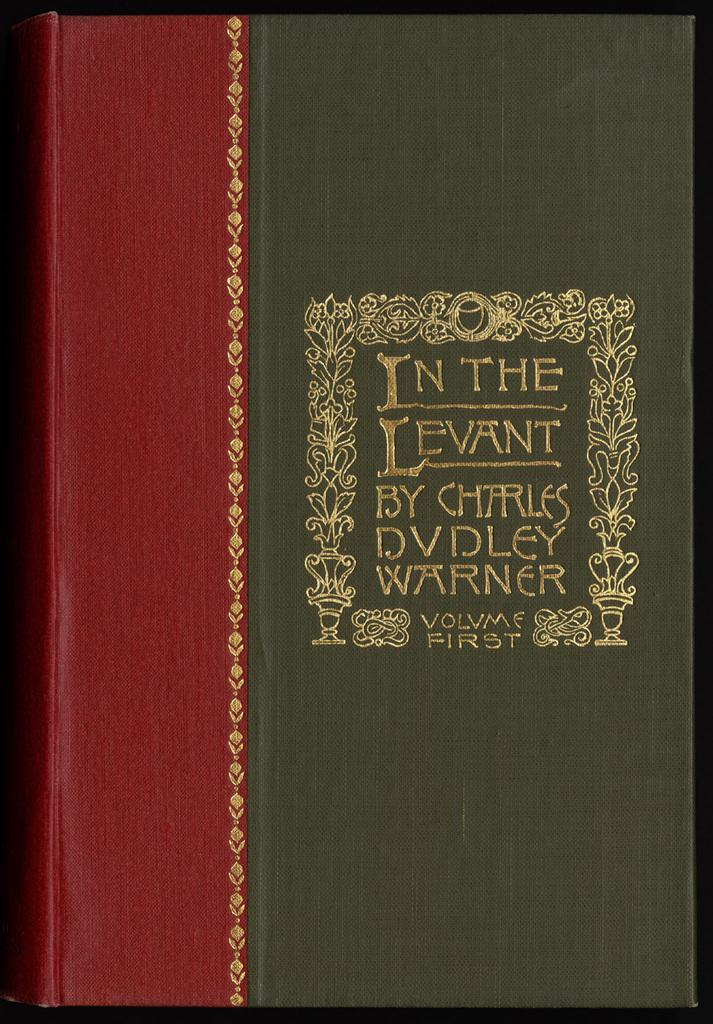<image>
Summarize the visual content of the image. The front of the book reads In the Levant. 